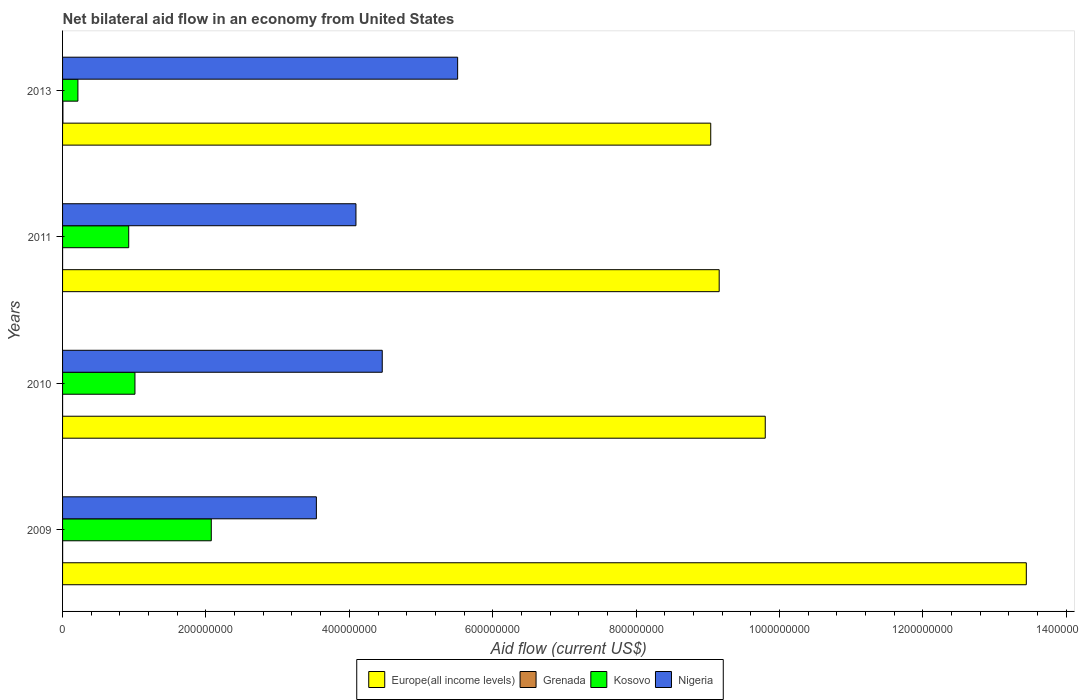How many different coloured bars are there?
Offer a terse response. 4. How many groups of bars are there?
Provide a succinct answer. 4. Are the number of bars per tick equal to the number of legend labels?
Provide a succinct answer. Yes. Are the number of bars on each tick of the Y-axis equal?
Provide a short and direct response. Yes. What is the label of the 2nd group of bars from the top?
Provide a short and direct response. 2011. In how many cases, is the number of bars for a given year not equal to the number of legend labels?
Keep it short and to the point. 0. What is the net bilateral aid flow in Kosovo in 2009?
Keep it short and to the point. 2.07e+08. Across all years, what is the maximum net bilateral aid flow in Nigeria?
Keep it short and to the point. 5.51e+08. Across all years, what is the minimum net bilateral aid flow in Grenada?
Keep it short and to the point. 2.00e+04. In which year was the net bilateral aid flow in Grenada minimum?
Give a very brief answer. 2010. What is the total net bilateral aid flow in Kosovo in the graph?
Keep it short and to the point. 4.22e+08. What is the difference between the net bilateral aid flow in Kosovo in 2009 and that in 2013?
Provide a succinct answer. 1.86e+08. What is the difference between the net bilateral aid flow in Nigeria in 2010 and the net bilateral aid flow in Kosovo in 2011?
Provide a succinct answer. 3.54e+08. What is the average net bilateral aid flow in Kosovo per year?
Your answer should be very brief. 1.06e+08. In the year 2009, what is the difference between the net bilateral aid flow in Grenada and net bilateral aid flow in Europe(all income levels)?
Your answer should be compact. -1.34e+09. What is the ratio of the net bilateral aid flow in Europe(all income levels) in 2010 to that in 2013?
Your answer should be very brief. 1.08. Is the difference between the net bilateral aid flow in Grenada in 2010 and 2011 greater than the difference between the net bilateral aid flow in Europe(all income levels) in 2010 and 2011?
Offer a very short reply. No. What is the difference between the highest and the second highest net bilateral aid flow in Nigeria?
Your response must be concise. 1.05e+08. Is the sum of the net bilateral aid flow in Nigeria in 2009 and 2010 greater than the maximum net bilateral aid flow in Kosovo across all years?
Make the answer very short. Yes. Is it the case that in every year, the sum of the net bilateral aid flow in Nigeria and net bilateral aid flow in Europe(all income levels) is greater than the sum of net bilateral aid flow in Grenada and net bilateral aid flow in Kosovo?
Your response must be concise. No. What does the 4th bar from the top in 2013 represents?
Keep it short and to the point. Europe(all income levels). What does the 1st bar from the bottom in 2010 represents?
Your answer should be very brief. Europe(all income levels). Is it the case that in every year, the sum of the net bilateral aid flow in Nigeria and net bilateral aid flow in Grenada is greater than the net bilateral aid flow in Europe(all income levels)?
Offer a terse response. No. Are all the bars in the graph horizontal?
Your answer should be very brief. Yes. How many years are there in the graph?
Your answer should be very brief. 4. Does the graph contain any zero values?
Keep it short and to the point. No. Does the graph contain grids?
Offer a very short reply. No. How many legend labels are there?
Give a very brief answer. 4. How are the legend labels stacked?
Make the answer very short. Horizontal. What is the title of the graph?
Offer a very short reply. Net bilateral aid flow in an economy from United States. What is the label or title of the Y-axis?
Keep it short and to the point. Years. What is the Aid flow (current US$) in Europe(all income levels) in 2009?
Provide a succinct answer. 1.34e+09. What is the Aid flow (current US$) of Grenada in 2009?
Provide a short and direct response. 8.00e+04. What is the Aid flow (current US$) of Kosovo in 2009?
Make the answer very short. 2.07e+08. What is the Aid flow (current US$) in Nigeria in 2009?
Provide a short and direct response. 3.54e+08. What is the Aid flow (current US$) of Europe(all income levels) in 2010?
Offer a terse response. 9.80e+08. What is the Aid flow (current US$) in Grenada in 2010?
Provide a short and direct response. 2.00e+04. What is the Aid flow (current US$) of Kosovo in 2010?
Your answer should be compact. 1.01e+08. What is the Aid flow (current US$) in Nigeria in 2010?
Keep it short and to the point. 4.46e+08. What is the Aid flow (current US$) in Europe(all income levels) in 2011?
Give a very brief answer. 9.16e+08. What is the Aid flow (current US$) of Grenada in 2011?
Your answer should be compact. 2.00e+04. What is the Aid flow (current US$) in Kosovo in 2011?
Provide a short and direct response. 9.23e+07. What is the Aid flow (current US$) in Nigeria in 2011?
Ensure brevity in your answer.  4.09e+08. What is the Aid flow (current US$) in Europe(all income levels) in 2013?
Make the answer very short. 9.04e+08. What is the Aid flow (current US$) in Kosovo in 2013?
Offer a terse response. 2.14e+07. What is the Aid flow (current US$) in Nigeria in 2013?
Ensure brevity in your answer.  5.51e+08. Across all years, what is the maximum Aid flow (current US$) in Europe(all income levels)?
Your answer should be very brief. 1.34e+09. Across all years, what is the maximum Aid flow (current US$) in Grenada?
Provide a short and direct response. 5.00e+05. Across all years, what is the maximum Aid flow (current US$) of Kosovo?
Ensure brevity in your answer.  2.07e+08. Across all years, what is the maximum Aid flow (current US$) of Nigeria?
Provide a succinct answer. 5.51e+08. Across all years, what is the minimum Aid flow (current US$) in Europe(all income levels)?
Make the answer very short. 9.04e+08. Across all years, what is the minimum Aid flow (current US$) of Kosovo?
Give a very brief answer. 2.14e+07. Across all years, what is the minimum Aid flow (current US$) of Nigeria?
Your answer should be very brief. 3.54e+08. What is the total Aid flow (current US$) in Europe(all income levels) in the graph?
Your answer should be very brief. 4.14e+09. What is the total Aid flow (current US$) of Grenada in the graph?
Your answer should be very brief. 6.20e+05. What is the total Aid flow (current US$) in Kosovo in the graph?
Offer a terse response. 4.22e+08. What is the total Aid flow (current US$) of Nigeria in the graph?
Provide a succinct answer. 1.76e+09. What is the difference between the Aid flow (current US$) in Europe(all income levels) in 2009 and that in 2010?
Ensure brevity in your answer.  3.64e+08. What is the difference between the Aid flow (current US$) of Kosovo in 2009 and that in 2010?
Offer a very short reply. 1.06e+08. What is the difference between the Aid flow (current US$) of Nigeria in 2009 and that in 2010?
Your response must be concise. -9.19e+07. What is the difference between the Aid flow (current US$) in Europe(all income levels) in 2009 and that in 2011?
Ensure brevity in your answer.  4.28e+08. What is the difference between the Aid flow (current US$) of Kosovo in 2009 and that in 2011?
Your answer should be compact. 1.15e+08. What is the difference between the Aid flow (current US$) of Nigeria in 2009 and that in 2011?
Offer a very short reply. -5.52e+07. What is the difference between the Aid flow (current US$) in Europe(all income levels) in 2009 and that in 2013?
Provide a short and direct response. 4.40e+08. What is the difference between the Aid flow (current US$) in Grenada in 2009 and that in 2013?
Offer a terse response. -4.20e+05. What is the difference between the Aid flow (current US$) in Kosovo in 2009 and that in 2013?
Give a very brief answer. 1.86e+08. What is the difference between the Aid flow (current US$) in Nigeria in 2009 and that in 2013?
Offer a terse response. -1.97e+08. What is the difference between the Aid flow (current US$) in Europe(all income levels) in 2010 and that in 2011?
Offer a terse response. 6.42e+07. What is the difference between the Aid flow (current US$) in Kosovo in 2010 and that in 2011?
Make the answer very short. 8.70e+06. What is the difference between the Aid flow (current US$) of Nigeria in 2010 and that in 2011?
Ensure brevity in your answer.  3.67e+07. What is the difference between the Aid flow (current US$) in Europe(all income levels) in 2010 and that in 2013?
Provide a succinct answer. 7.60e+07. What is the difference between the Aid flow (current US$) in Grenada in 2010 and that in 2013?
Make the answer very short. -4.80e+05. What is the difference between the Aid flow (current US$) of Kosovo in 2010 and that in 2013?
Your response must be concise. 7.96e+07. What is the difference between the Aid flow (current US$) in Nigeria in 2010 and that in 2013?
Make the answer very short. -1.05e+08. What is the difference between the Aid flow (current US$) in Europe(all income levels) in 2011 and that in 2013?
Keep it short and to the point. 1.18e+07. What is the difference between the Aid flow (current US$) of Grenada in 2011 and that in 2013?
Your answer should be compact. -4.80e+05. What is the difference between the Aid flow (current US$) in Kosovo in 2011 and that in 2013?
Offer a terse response. 7.09e+07. What is the difference between the Aid flow (current US$) of Nigeria in 2011 and that in 2013?
Ensure brevity in your answer.  -1.42e+08. What is the difference between the Aid flow (current US$) of Europe(all income levels) in 2009 and the Aid flow (current US$) of Grenada in 2010?
Provide a short and direct response. 1.34e+09. What is the difference between the Aid flow (current US$) of Europe(all income levels) in 2009 and the Aid flow (current US$) of Kosovo in 2010?
Your answer should be very brief. 1.24e+09. What is the difference between the Aid flow (current US$) in Europe(all income levels) in 2009 and the Aid flow (current US$) in Nigeria in 2010?
Your answer should be very brief. 8.98e+08. What is the difference between the Aid flow (current US$) of Grenada in 2009 and the Aid flow (current US$) of Kosovo in 2010?
Offer a very short reply. -1.01e+08. What is the difference between the Aid flow (current US$) in Grenada in 2009 and the Aid flow (current US$) in Nigeria in 2010?
Keep it short and to the point. -4.46e+08. What is the difference between the Aid flow (current US$) in Kosovo in 2009 and the Aid flow (current US$) in Nigeria in 2010?
Give a very brief answer. -2.38e+08. What is the difference between the Aid flow (current US$) of Europe(all income levels) in 2009 and the Aid flow (current US$) of Grenada in 2011?
Offer a very short reply. 1.34e+09. What is the difference between the Aid flow (current US$) in Europe(all income levels) in 2009 and the Aid flow (current US$) in Kosovo in 2011?
Your response must be concise. 1.25e+09. What is the difference between the Aid flow (current US$) in Europe(all income levels) in 2009 and the Aid flow (current US$) in Nigeria in 2011?
Your answer should be very brief. 9.35e+08. What is the difference between the Aid flow (current US$) of Grenada in 2009 and the Aid flow (current US$) of Kosovo in 2011?
Make the answer very short. -9.22e+07. What is the difference between the Aid flow (current US$) in Grenada in 2009 and the Aid flow (current US$) in Nigeria in 2011?
Give a very brief answer. -4.09e+08. What is the difference between the Aid flow (current US$) of Kosovo in 2009 and the Aid flow (current US$) of Nigeria in 2011?
Provide a short and direct response. -2.02e+08. What is the difference between the Aid flow (current US$) of Europe(all income levels) in 2009 and the Aid flow (current US$) of Grenada in 2013?
Offer a very short reply. 1.34e+09. What is the difference between the Aid flow (current US$) of Europe(all income levels) in 2009 and the Aid flow (current US$) of Kosovo in 2013?
Offer a terse response. 1.32e+09. What is the difference between the Aid flow (current US$) in Europe(all income levels) in 2009 and the Aid flow (current US$) in Nigeria in 2013?
Keep it short and to the point. 7.93e+08. What is the difference between the Aid flow (current US$) in Grenada in 2009 and the Aid flow (current US$) in Kosovo in 2013?
Offer a very short reply. -2.13e+07. What is the difference between the Aid flow (current US$) of Grenada in 2009 and the Aid flow (current US$) of Nigeria in 2013?
Offer a very short reply. -5.51e+08. What is the difference between the Aid flow (current US$) of Kosovo in 2009 and the Aid flow (current US$) of Nigeria in 2013?
Give a very brief answer. -3.44e+08. What is the difference between the Aid flow (current US$) in Europe(all income levels) in 2010 and the Aid flow (current US$) in Grenada in 2011?
Offer a terse response. 9.80e+08. What is the difference between the Aid flow (current US$) in Europe(all income levels) in 2010 and the Aid flow (current US$) in Kosovo in 2011?
Offer a terse response. 8.88e+08. What is the difference between the Aid flow (current US$) of Europe(all income levels) in 2010 and the Aid flow (current US$) of Nigeria in 2011?
Keep it short and to the point. 5.71e+08. What is the difference between the Aid flow (current US$) of Grenada in 2010 and the Aid flow (current US$) of Kosovo in 2011?
Offer a very short reply. -9.22e+07. What is the difference between the Aid flow (current US$) in Grenada in 2010 and the Aid flow (current US$) in Nigeria in 2011?
Your response must be concise. -4.09e+08. What is the difference between the Aid flow (current US$) of Kosovo in 2010 and the Aid flow (current US$) of Nigeria in 2011?
Offer a terse response. -3.08e+08. What is the difference between the Aid flow (current US$) in Europe(all income levels) in 2010 and the Aid flow (current US$) in Grenada in 2013?
Give a very brief answer. 9.80e+08. What is the difference between the Aid flow (current US$) of Europe(all income levels) in 2010 and the Aid flow (current US$) of Kosovo in 2013?
Give a very brief answer. 9.59e+08. What is the difference between the Aid flow (current US$) in Europe(all income levels) in 2010 and the Aid flow (current US$) in Nigeria in 2013?
Ensure brevity in your answer.  4.29e+08. What is the difference between the Aid flow (current US$) in Grenada in 2010 and the Aid flow (current US$) in Kosovo in 2013?
Ensure brevity in your answer.  -2.14e+07. What is the difference between the Aid flow (current US$) in Grenada in 2010 and the Aid flow (current US$) in Nigeria in 2013?
Your answer should be very brief. -5.51e+08. What is the difference between the Aid flow (current US$) in Kosovo in 2010 and the Aid flow (current US$) in Nigeria in 2013?
Your answer should be very brief. -4.50e+08. What is the difference between the Aid flow (current US$) of Europe(all income levels) in 2011 and the Aid flow (current US$) of Grenada in 2013?
Make the answer very short. 9.15e+08. What is the difference between the Aid flow (current US$) of Europe(all income levels) in 2011 and the Aid flow (current US$) of Kosovo in 2013?
Provide a succinct answer. 8.94e+08. What is the difference between the Aid flow (current US$) of Europe(all income levels) in 2011 and the Aid flow (current US$) of Nigeria in 2013?
Ensure brevity in your answer.  3.65e+08. What is the difference between the Aid flow (current US$) of Grenada in 2011 and the Aid flow (current US$) of Kosovo in 2013?
Provide a succinct answer. -2.14e+07. What is the difference between the Aid flow (current US$) of Grenada in 2011 and the Aid flow (current US$) of Nigeria in 2013?
Make the answer very short. -5.51e+08. What is the difference between the Aid flow (current US$) of Kosovo in 2011 and the Aid flow (current US$) of Nigeria in 2013?
Make the answer very short. -4.59e+08. What is the average Aid flow (current US$) in Europe(all income levels) per year?
Provide a short and direct response. 1.04e+09. What is the average Aid flow (current US$) of Grenada per year?
Provide a short and direct response. 1.55e+05. What is the average Aid flow (current US$) in Kosovo per year?
Give a very brief answer. 1.06e+08. What is the average Aid flow (current US$) of Nigeria per year?
Offer a terse response. 4.40e+08. In the year 2009, what is the difference between the Aid flow (current US$) of Europe(all income levels) and Aid flow (current US$) of Grenada?
Offer a very short reply. 1.34e+09. In the year 2009, what is the difference between the Aid flow (current US$) in Europe(all income levels) and Aid flow (current US$) in Kosovo?
Your response must be concise. 1.14e+09. In the year 2009, what is the difference between the Aid flow (current US$) of Europe(all income levels) and Aid flow (current US$) of Nigeria?
Offer a terse response. 9.90e+08. In the year 2009, what is the difference between the Aid flow (current US$) in Grenada and Aid flow (current US$) in Kosovo?
Your response must be concise. -2.07e+08. In the year 2009, what is the difference between the Aid flow (current US$) of Grenada and Aid flow (current US$) of Nigeria?
Keep it short and to the point. -3.54e+08. In the year 2009, what is the difference between the Aid flow (current US$) of Kosovo and Aid flow (current US$) of Nigeria?
Keep it short and to the point. -1.47e+08. In the year 2010, what is the difference between the Aid flow (current US$) of Europe(all income levels) and Aid flow (current US$) of Grenada?
Give a very brief answer. 9.80e+08. In the year 2010, what is the difference between the Aid flow (current US$) of Europe(all income levels) and Aid flow (current US$) of Kosovo?
Provide a succinct answer. 8.79e+08. In the year 2010, what is the difference between the Aid flow (current US$) of Europe(all income levels) and Aid flow (current US$) of Nigeria?
Give a very brief answer. 5.34e+08. In the year 2010, what is the difference between the Aid flow (current US$) of Grenada and Aid flow (current US$) of Kosovo?
Keep it short and to the point. -1.01e+08. In the year 2010, what is the difference between the Aid flow (current US$) in Grenada and Aid flow (current US$) in Nigeria?
Make the answer very short. -4.46e+08. In the year 2010, what is the difference between the Aid flow (current US$) of Kosovo and Aid flow (current US$) of Nigeria?
Give a very brief answer. -3.45e+08. In the year 2011, what is the difference between the Aid flow (current US$) in Europe(all income levels) and Aid flow (current US$) in Grenada?
Ensure brevity in your answer.  9.16e+08. In the year 2011, what is the difference between the Aid flow (current US$) of Europe(all income levels) and Aid flow (current US$) of Kosovo?
Ensure brevity in your answer.  8.24e+08. In the year 2011, what is the difference between the Aid flow (current US$) of Europe(all income levels) and Aid flow (current US$) of Nigeria?
Make the answer very short. 5.07e+08. In the year 2011, what is the difference between the Aid flow (current US$) of Grenada and Aid flow (current US$) of Kosovo?
Provide a short and direct response. -9.22e+07. In the year 2011, what is the difference between the Aid flow (current US$) of Grenada and Aid flow (current US$) of Nigeria?
Keep it short and to the point. -4.09e+08. In the year 2011, what is the difference between the Aid flow (current US$) of Kosovo and Aid flow (current US$) of Nigeria?
Your answer should be very brief. -3.17e+08. In the year 2013, what is the difference between the Aid flow (current US$) in Europe(all income levels) and Aid flow (current US$) in Grenada?
Keep it short and to the point. 9.04e+08. In the year 2013, what is the difference between the Aid flow (current US$) of Europe(all income levels) and Aid flow (current US$) of Kosovo?
Your answer should be very brief. 8.83e+08. In the year 2013, what is the difference between the Aid flow (current US$) in Europe(all income levels) and Aid flow (current US$) in Nigeria?
Keep it short and to the point. 3.53e+08. In the year 2013, what is the difference between the Aid flow (current US$) of Grenada and Aid flow (current US$) of Kosovo?
Your response must be concise. -2.09e+07. In the year 2013, what is the difference between the Aid flow (current US$) of Grenada and Aid flow (current US$) of Nigeria?
Make the answer very short. -5.51e+08. In the year 2013, what is the difference between the Aid flow (current US$) in Kosovo and Aid flow (current US$) in Nigeria?
Give a very brief answer. -5.30e+08. What is the ratio of the Aid flow (current US$) in Europe(all income levels) in 2009 to that in 2010?
Provide a succinct answer. 1.37. What is the ratio of the Aid flow (current US$) in Grenada in 2009 to that in 2010?
Your answer should be compact. 4. What is the ratio of the Aid flow (current US$) in Kosovo in 2009 to that in 2010?
Keep it short and to the point. 2.05. What is the ratio of the Aid flow (current US$) in Nigeria in 2009 to that in 2010?
Keep it short and to the point. 0.79. What is the ratio of the Aid flow (current US$) in Europe(all income levels) in 2009 to that in 2011?
Provide a succinct answer. 1.47. What is the ratio of the Aid flow (current US$) of Kosovo in 2009 to that in 2011?
Ensure brevity in your answer.  2.25. What is the ratio of the Aid flow (current US$) of Nigeria in 2009 to that in 2011?
Provide a succinct answer. 0.87. What is the ratio of the Aid flow (current US$) in Europe(all income levels) in 2009 to that in 2013?
Keep it short and to the point. 1.49. What is the ratio of the Aid flow (current US$) in Grenada in 2009 to that in 2013?
Your answer should be compact. 0.16. What is the ratio of the Aid flow (current US$) in Kosovo in 2009 to that in 2013?
Offer a terse response. 9.7. What is the ratio of the Aid flow (current US$) in Nigeria in 2009 to that in 2013?
Offer a terse response. 0.64. What is the ratio of the Aid flow (current US$) in Europe(all income levels) in 2010 to that in 2011?
Offer a very short reply. 1.07. What is the ratio of the Aid flow (current US$) in Grenada in 2010 to that in 2011?
Your answer should be compact. 1. What is the ratio of the Aid flow (current US$) of Kosovo in 2010 to that in 2011?
Ensure brevity in your answer.  1.09. What is the ratio of the Aid flow (current US$) in Nigeria in 2010 to that in 2011?
Your answer should be very brief. 1.09. What is the ratio of the Aid flow (current US$) in Europe(all income levels) in 2010 to that in 2013?
Give a very brief answer. 1.08. What is the ratio of the Aid flow (current US$) of Kosovo in 2010 to that in 2013?
Your answer should be compact. 4.72. What is the ratio of the Aid flow (current US$) of Nigeria in 2010 to that in 2013?
Keep it short and to the point. 0.81. What is the ratio of the Aid flow (current US$) in Europe(all income levels) in 2011 to that in 2013?
Your response must be concise. 1.01. What is the ratio of the Aid flow (current US$) of Grenada in 2011 to that in 2013?
Ensure brevity in your answer.  0.04. What is the ratio of the Aid flow (current US$) of Kosovo in 2011 to that in 2013?
Provide a short and direct response. 4.31. What is the ratio of the Aid flow (current US$) of Nigeria in 2011 to that in 2013?
Offer a terse response. 0.74. What is the difference between the highest and the second highest Aid flow (current US$) of Europe(all income levels)?
Provide a short and direct response. 3.64e+08. What is the difference between the highest and the second highest Aid flow (current US$) in Grenada?
Your response must be concise. 4.20e+05. What is the difference between the highest and the second highest Aid flow (current US$) of Kosovo?
Your answer should be compact. 1.06e+08. What is the difference between the highest and the second highest Aid flow (current US$) of Nigeria?
Provide a succinct answer. 1.05e+08. What is the difference between the highest and the lowest Aid flow (current US$) in Europe(all income levels)?
Offer a very short reply. 4.40e+08. What is the difference between the highest and the lowest Aid flow (current US$) in Kosovo?
Keep it short and to the point. 1.86e+08. What is the difference between the highest and the lowest Aid flow (current US$) of Nigeria?
Keep it short and to the point. 1.97e+08. 